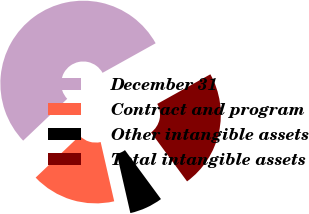<chart> <loc_0><loc_0><loc_500><loc_500><pie_chart><fcel>December 31<fcel>Contract and program<fcel>Other intangible assets<fcel>Total intangible assets<nl><fcel>54.01%<fcel>16.49%<fcel>6.51%<fcel>23.0%<nl></chart> 